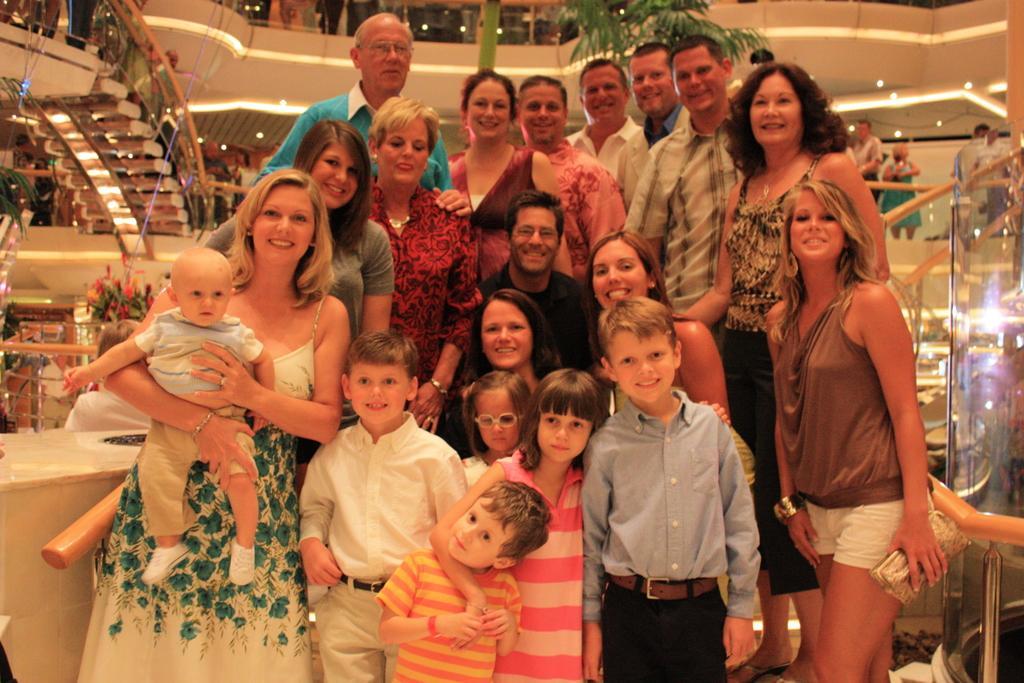How would you summarize this image in a sentence or two? In this image I can see few children and number of people are standing. I can see smile on their faces and here I can see she is holding a baby. In the background I can see few more people, few lights and green colour leaves. 